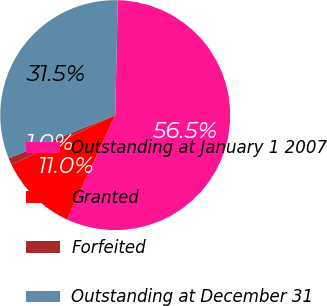Convert chart to OTSL. <chart><loc_0><loc_0><loc_500><loc_500><pie_chart><fcel>Outstanding at January 1 2007<fcel>Granted<fcel>Forfeited<fcel>Outstanding at December 31<nl><fcel>56.54%<fcel>11.02%<fcel>0.97%<fcel>31.47%<nl></chart> 